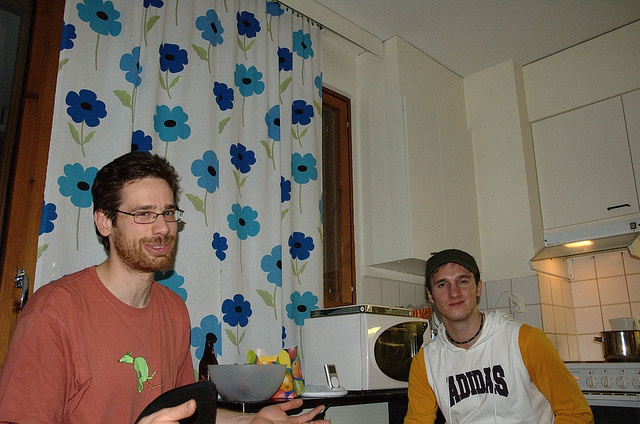Describe the objects in this image and their specific colors. I can see people in black, brown, and maroon tones, people in black, darkgray, olive, and maroon tones, microwave in black, darkgray, gray, and olive tones, oven in black and gray tones, and bowl in black, gray, and purple tones in this image. 